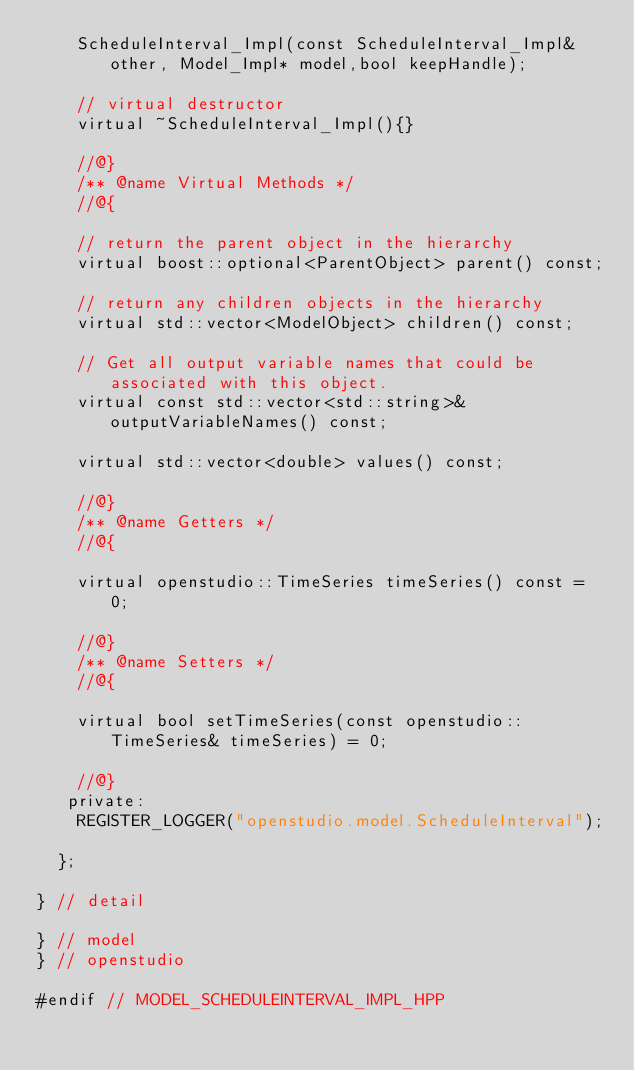Convert code to text. <code><loc_0><loc_0><loc_500><loc_500><_C++_>    ScheduleInterval_Impl(const ScheduleInterval_Impl& other, Model_Impl* model,bool keepHandle);

    // virtual destructor
    virtual ~ScheduleInterval_Impl(){}

    //@}
    /** @name Virtual Methods */
    //@{

    // return the parent object in the hierarchy
    virtual boost::optional<ParentObject> parent() const;

    // return any children objects in the hierarchy
    virtual std::vector<ModelObject> children() const;

    // Get all output variable names that could be associated with this object.
    virtual const std::vector<std::string>& outputVariableNames() const;

    virtual std::vector<double> values() const;

    //@}
    /** @name Getters */
    //@{

    virtual openstudio::TimeSeries timeSeries() const = 0;

    //@}
    /** @name Setters */
    //@{

    virtual bool setTimeSeries(const openstudio::TimeSeries& timeSeries) = 0;

    //@}
   private:
    REGISTER_LOGGER("openstudio.model.ScheduleInterval");

  };

} // detail

} // model
} // openstudio

#endif // MODEL_SCHEDULEINTERVAL_IMPL_HPP
</code> 